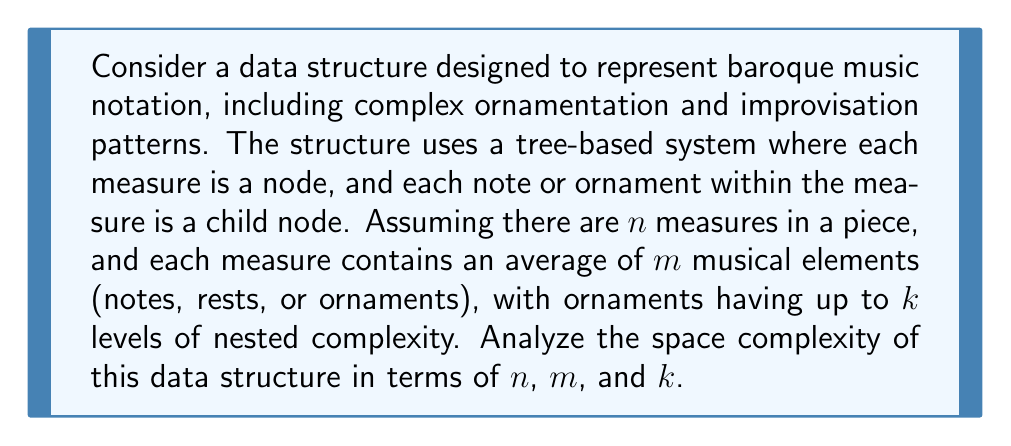Teach me how to tackle this problem. To analyze the space complexity of this data structure, we need to consider the storage requirements for each component:

1. Measure nodes:
   - There are $n$ measure nodes in total.
   - Each measure node requires constant space, let's say $c_1$.
   - Space for measure nodes: $O(n \cdot c_1) = O(n)$

2. Musical elements within measures:
   - Each measure contains an average of $m$ musical elements.
   - Total number of musical elements: $n \cdot m$
   - Each musical element requires constant space, let's say $c_2$.
   - Space for musical elements: $O(n \cdot m \cdot c_2) = O(nm)$

3. Ornaments with nested complexity:
   - Ornaments can have up to $k$ levels of nested complexity.
   - In the worst case, each musical element could be an ornament with maximum complexity.
   - The space required for each ornament follows a geometric series: $1 + k + k^2 + ... + k^{k-1}$
   - This series sums to: $\frac{k^k - 1}{k - 1}$
   - Total space for ornaments: $O(n \cdot m \cdot \frac{k^k - 1}{k - 1})$

Combining all components, the total space complexity is:

$$O(n + nm + nm \cdot \frac{k^k - 1}{k - 1})$$

Simplifying this expression:

$$O(n(1 + m + m \cdot \frac{k^k - 1}{k - 1}))$$

Since $m$ and $k$ are typically much smaller than $n$, we can consider them as constants. However, the term $\frac{k^k - 1}{k - 1}$ grows exponentially with $k$, so it's important to keep it in the final expression.

Therefore, the space complexity can be expressed as:

$$O(n \cdot \frac{k^k - 1}{k - 1})$$

This represents the worst-case scenario where every musical element is a complex ornament with maximum nesting.
Answer: The space complexity of the data structure is $O(n \cdot \frac{k^k - 1}{k - 1})$, where $n$ is the number of measures, and $k$ is the maximum level of nested complexity in ornaments. 